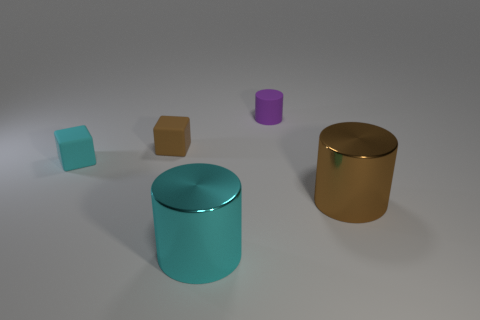Add 1 big blue blocks. How many objects exist? 6 Subtract all small purple matte cylinders. How many cylinders are left? 2 Subtract all brown cubes. How many cubes are left? 1 Subtract all cubes. How many objects are left? 3 Subtract all yellow cylinders. Subtract all gray spheres. How many cylinders are left? 3 Subtract all large rubber cubes. Subtract all cyan matte cubes. How many objects are left? 4 Add 5 tiny cyan matte blocks. How many tiny cyan matte blocks are left? 6 Add 5 purple matte cylinders. How many purple matte cylinders exist? 6 Subtract 0 blue spheres. How many objects are left? 5 